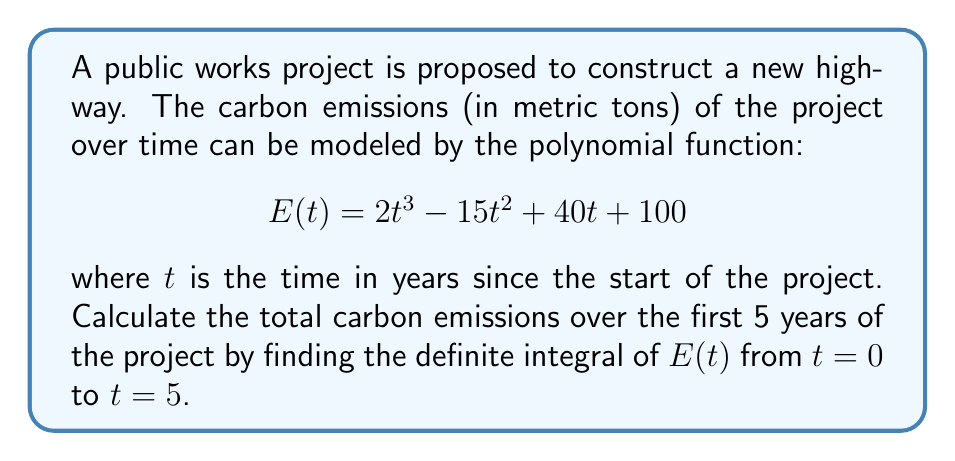Teach me how to tackle this problem. To calculate the total carbon emissions over the first 5 years, we need to integrate the function $E(t)$ from 0 to 5. This will give us the area under the curve, which represents the cumulative emissions over time.

1) First, let's integrate the function $E(t)$:

   $$\int E(t) dt = \int (2t^3 - 15t^2 + 40t + 100) dt$$

2) Integrating each term:
   
   $$\int 2t^3 dt = \frac{1}{2}t^4$$
   $$\int -15t^2 dt = -5t^3$$
   $$\int 40t dt = 20t^2$$
   $$\int 100 dt = 100t$$

3) Combining these, we get the indefinite integral:

   $$\int E(t) dt = \frac{1}{2}t^4 - 5t^3 + 20t^2 + 100t + C$$

4) Now, we need to evaluate this from $t=0$ to $t=5$. Let's call our indefinite integral $F(t)$:

   $$\int_0^5 E(t) dt = F(5) - F(0)$$

5) Evaluating $F(5)$:
   
   $$F(5) = \frac{1}{2}(5^4) - 5(5^3) + 20(5^2) + 100(5) = 312.5 - 625 + 500 + 500 = 687.5$$

6) Evaluating $F(0)$:
   
   $$F(0) = \frac{1}{2}(0^4) - 5(0^3) + 20(0^2) + 100(0) = 0$$

7) Therefore, the definite integral is:

   $$\int_0^5 E(t) dt = 687.5 - 0 = 687.5$$

This means the total carbon emissions over the first 5 years of the project are 687.5 metric tons.
Answer: 687.5 metric tons of carbon emissions 